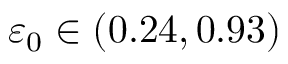Convert formula to latex. <formula><loc_0><loc_0><loc_500><loc_500>{ \varepsilon _ { 0 } } \in ( 0 . 2 4 , 0 . 9 3 )</formula> 